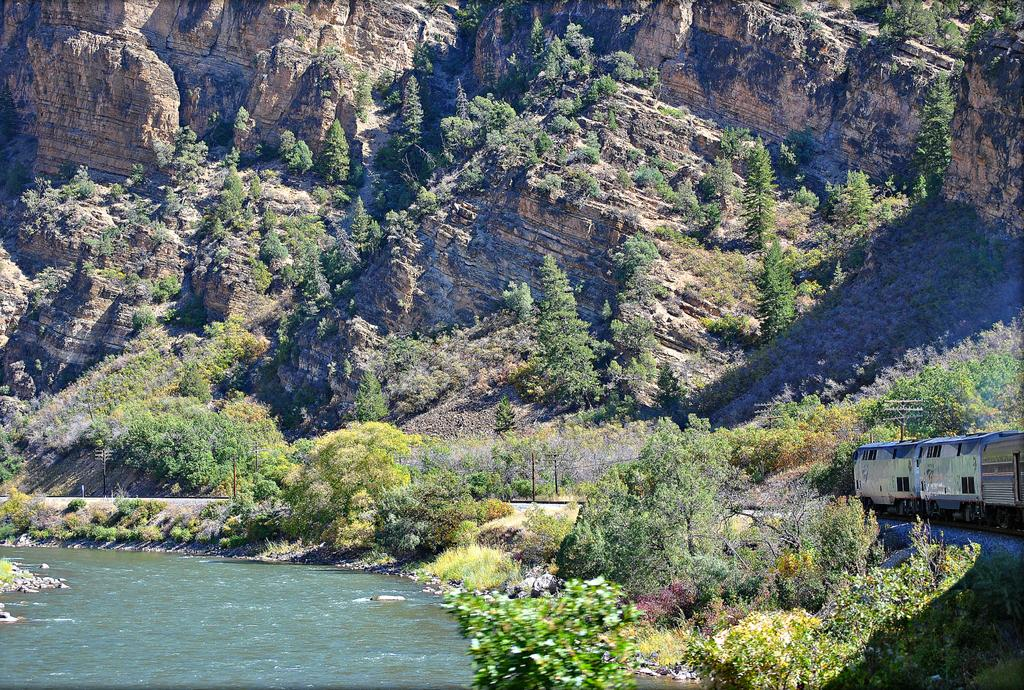What type of setting is depicted in the image? The image is an outdoor scene. What mode of transportation can be seen in the image? There is a train on a train track in the image. What color are the trees in the image? The trees in the image have green color. What body of water is present in the image? There is a river with fresh water in the image. What geographical feature can be seen in the background of the image? There is a mountain in the image. How many points does the sky have in the image? The sky does not have points in the image; it is a continuous expanse of the atmosphere. 